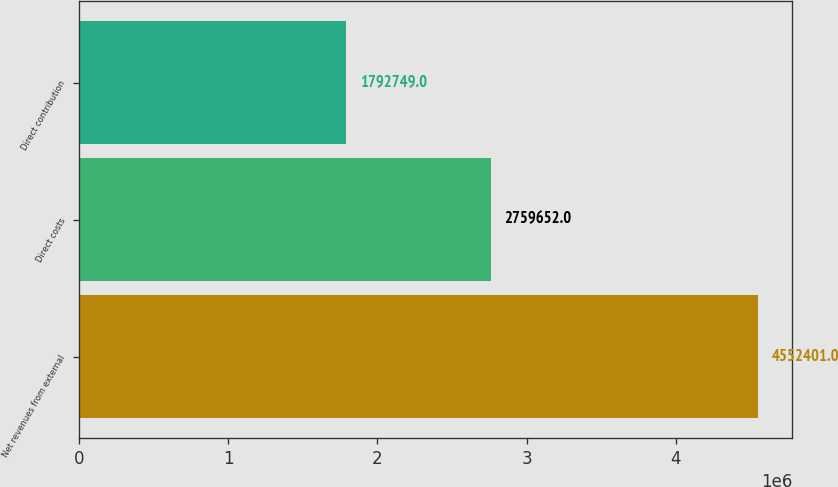Convert chart. <chart><loc_0><loc_0><loc_500><loc_500><bar_chart><fcel>Net revenues from external<fcel>Direct costs<fcel>Direct contribution<nl><fcel>4.5524e+06<fcel>2.75965e+06<fcel>1.79275e+06<nl></chart> 